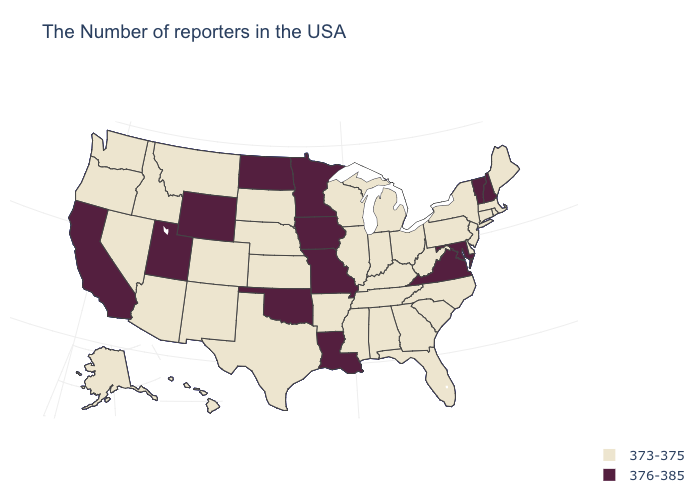What is the highest value in the West ?
Keep it brief. 376-385. How many symbols are there in the legend?
Keep it brief. 2. Does the first symbol in the legend represent the smallest category?
Answer briefly. Yes. Does North Dakota have the same value as Kansas?
Write a very short answer. No. Name the states that have a value in the range 373-375?
Give a very brief answer. Maine, Massachusetts, Rhode Island, Connecticut, New York, New Jersey, Delaware, Pennsylvania, North Carolina, South Carolina, West Virginia, Ohio, Florida, Georgia, Michigan, Kentucky, Indiana, Alabama, Tennessee, Wisconsin, Illinois, Mississippi, Arkansas, Kansas, Nebraska, Texas, South Dakota, Colorado, New Mexico, Montana, Arizona, Idaho, Nevada, Washington, Oregon, Alaska, Hawaii. What is the lowest value in the West?
Short answer required. 373-375. Which states hav the highest value in the South?
Concise answer only. Maryland, Virginia, Louisiana, Oklahoma. Among the states that border New York , which have the highest value?
Keep it brief. Vermont. Is the legend a continuous bar?
Be succinct. No. What is the value of Utah?
Keep it brief. 376-385. What is the lowest value in states that border Missouri?
Keep it brief. 373-375. Name the states that have a value in the range 373-375?
Keep it brief. Maine, Massachusetts, Rhode Island, Connecticut, New York, New Jersey, Delaware, Pennsylvania, North Carolina, South Carolina, West Virginia, Ohio, Florida, Georgia, Michigan, Kentucky, Indiana, Alabama, Tennessee, Wisconsin, Illinois, Mississippi, Arkansas, Kansas, Nebraska, Texas, South Dakota, Colorado, New Mexico, Montana, Arizona, Idaho, Nevada, Washington, Oregon, Alaska, Hawaii. Name the states that have a value in the range 373-375?
Keep it brief. Maine, Massachusetts, Rhode Island, Connecticut, New York, New Jersey, Delaware, Pennsylvania, North Carolina, South Carolina, West Virginia, Ohio, Florida, Georgia, Michigan, Kentucky, Indiana, Alabama, Tennessee, Wisconsin, Illinois, Mississippi, Arkansas, Kansas, Nebraska, Texas, South Dakota, Colorado, New Mexico, Montana, Arizona, Idaho, Nevada, Washington, Oregon, Alaska, Hawaii. Does Minnesota have the highest value in the MidWest?
Write a very short answer. Yes. What is the lowest value in the USA?
Keep it brief. 373-375. 